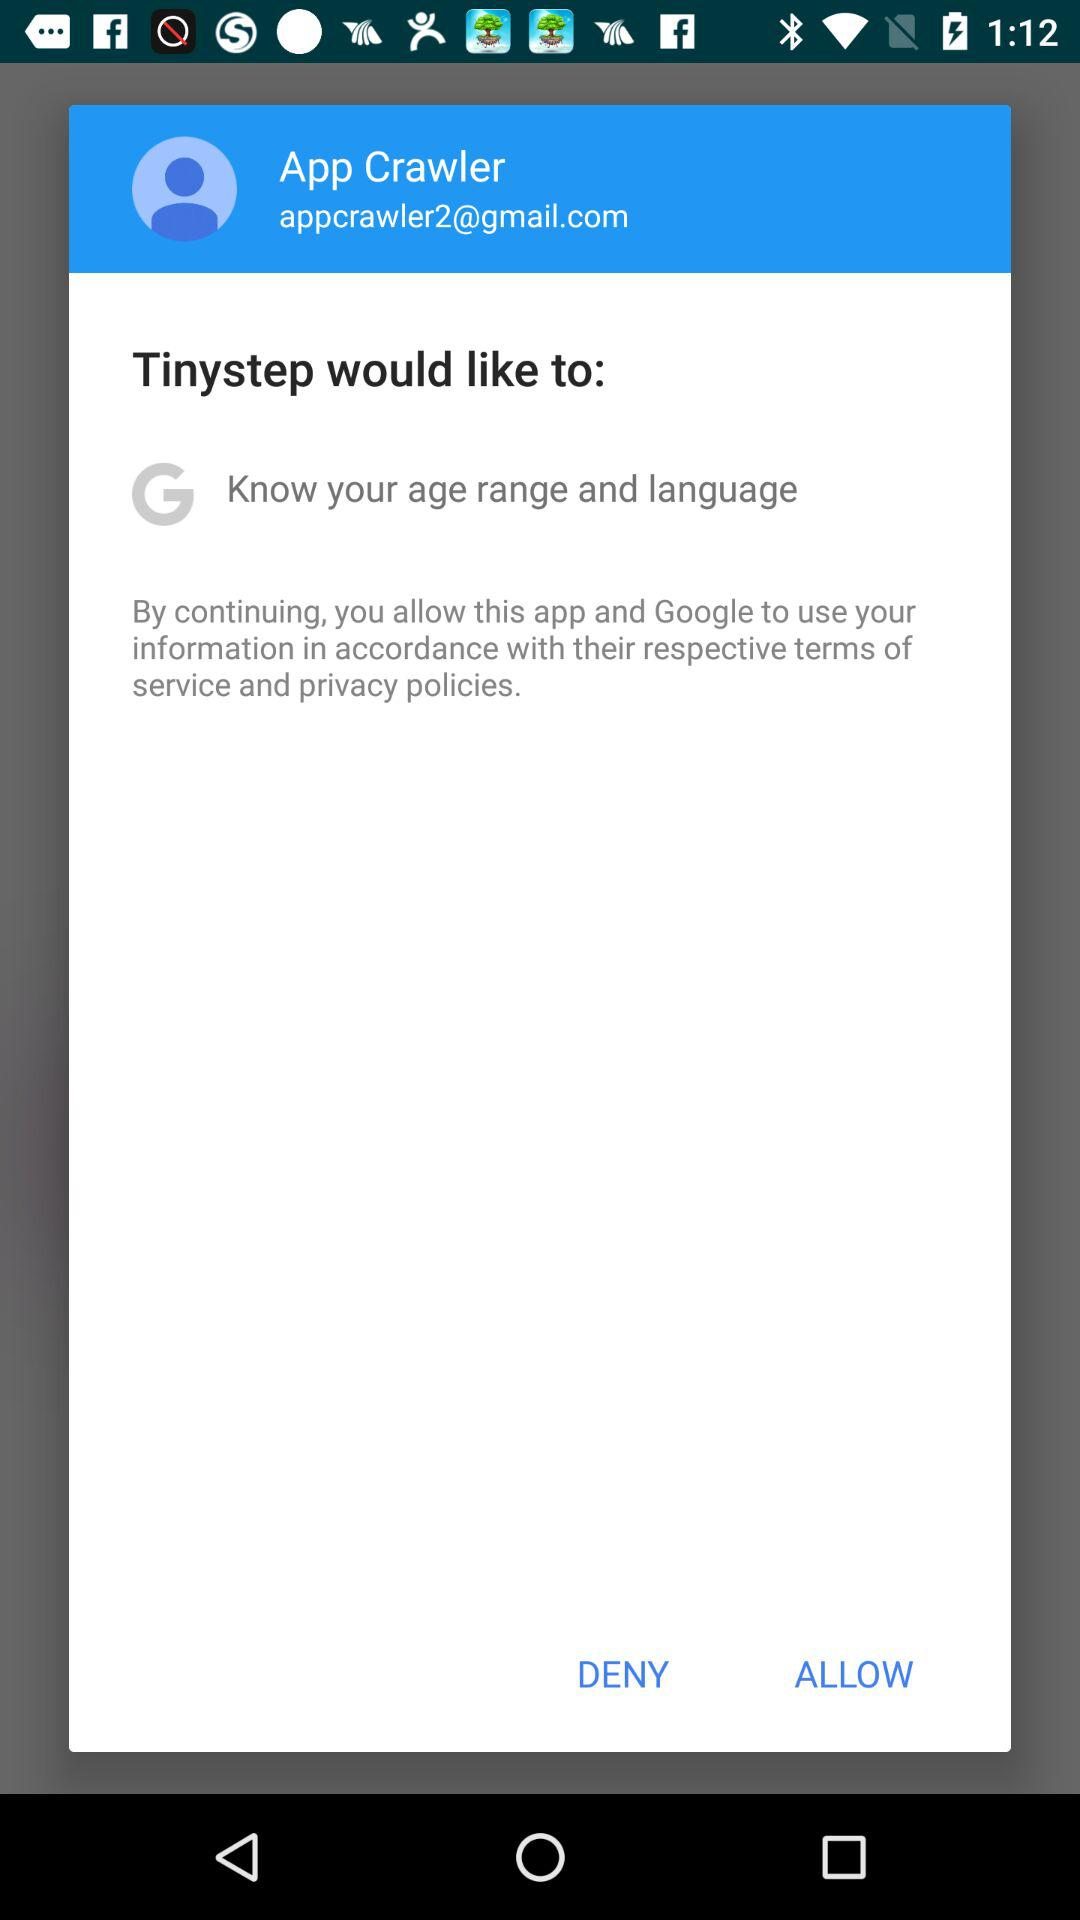What is the email address? The email address is appcrawler2@gmail.com. 